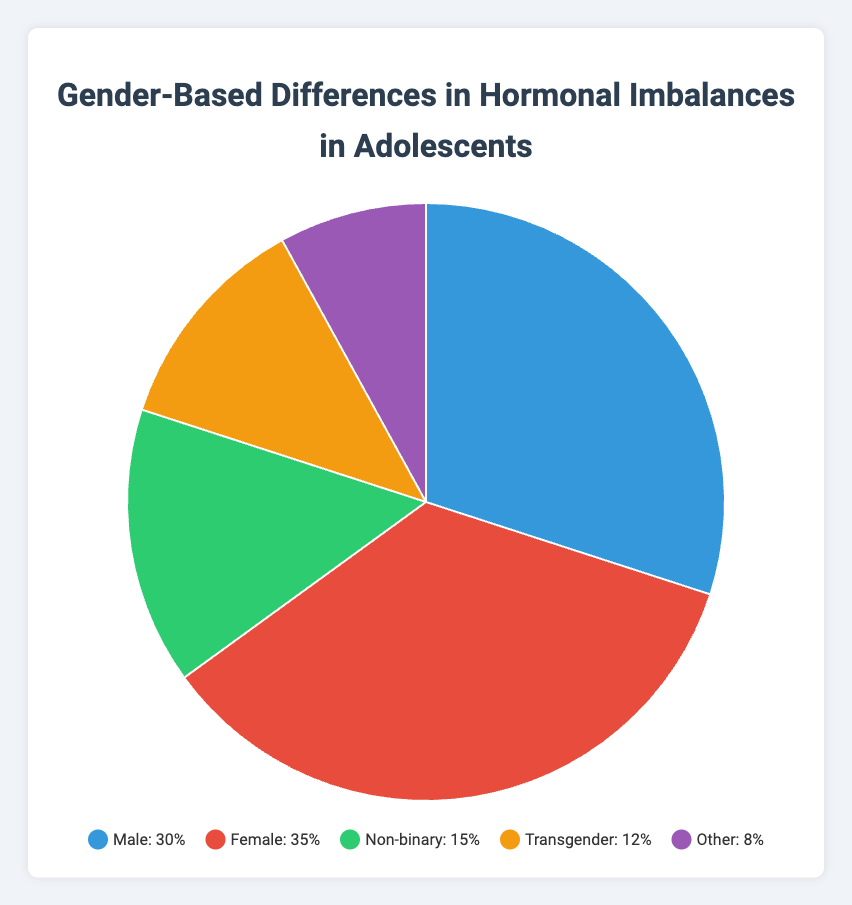What's the most common category of hormonal imbalances among adolescents according to the figure? Looking at the figure, the largest slice is labeled "Female" and makes up 35% of the chart, which is the highest percentage.
Answer: Female Which category has the least percentage of hormonal imbalances? The smallest slice in the pie chart is labeled "Other" and makes up 8% of the chart, which is the lowest percentage.
Answer: Other How do the percentages of Male and Female categories compare? The percentage for Male is 30%, and for Female it is 35%. Comparing these two, Female has a larger percentage than Male.
Answer: Female > Male What is the combined percentage for Non-binary and Transgender categories? Adding the percentages for Non-binary (15%) and Transgender (12%) gives 15% + 12% = 27%.
Answer: 27% How much greater is the percentage of Females compared to that of Transgenders? The percentage for Females is 35% and for Transgenders is 12%. Subtracting these, 35% - 12% = 23%.
Answer: 23% Which two categories together make up almost half of the pie chart? Adding the percentages for Female (35%) and Male (30%) gives 35% + 30% = 65%, which is more than half but represents the largest combined slice. However, looking for almost half, adding Non-binary (15%) + Transgender (12%) makes 27%, or Close, Male (30%) + Non-binary (15%) results in 45% which is close to half. Neither make exactly half but the Male category would be a significant contender combined with another.
Answer: Female and Male What visual cue indicates that the Female category is the largest segment in the chart? The Female category's slice is visibly the largest section and occupies the most space in the pie chart.
Answer: Largest slice Calculate the percentage difference between the Male and Non-binary categories. Subtract Non-binary (15%) from Male (30%): 30% - 15% = 15%.
Answer: 15% If you were to combine the Male, Female, and Non-binary categories, what percentage of the total would that be? Adding the percentages of Male (30%), Female (35%), and Non-binary (15%) gives 30% + 35% + 15% = 80%.
Answer: 80% 